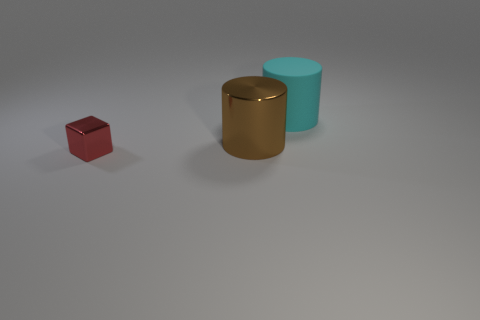Add 1 blue shiny cylinders. How many objects exist? 4 Subtract all cylinders. How many objects are left? 1 Subtract 0 green spheres. How many objects are left? 3 Subtract all red cubes. Subtract all big brown things. How many objects are left? 1 Add 2 tiny metal cubes. How many tiny metal cubes are left? 3 Add 1 gray cylinders. How many gray cylinders exist? 1 